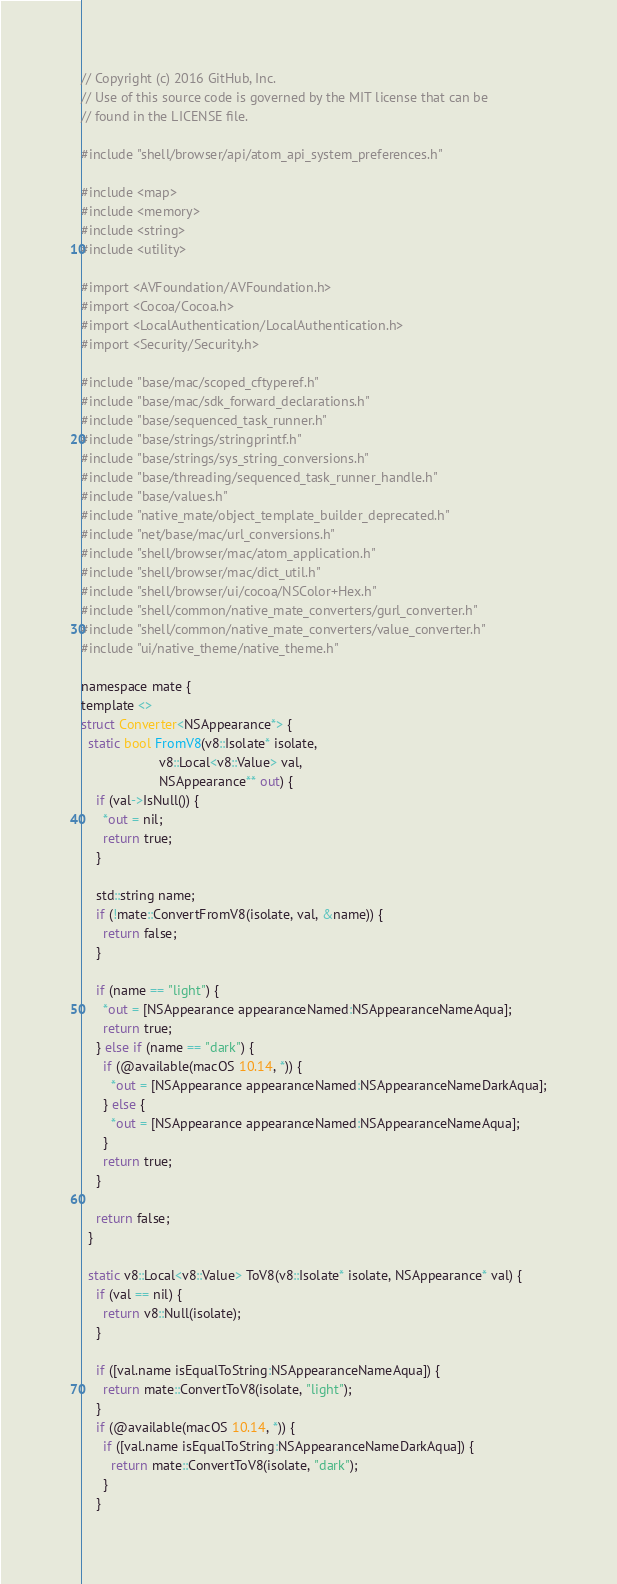Convert code to text. <code><loc_0><loc_0><loc_500><loc_500><_ObjectiveC_>// Copyright (c) 2016 GitHub, Inc.
// Use of this source code is governed by the MIT license that can be
// found in the LICENSE file.

#include "shell/browser/api/atom_api_system_preferences.h"

#include <map>
#include <memory>
#include <string>
#include <utility>

#import <AVFoundation/AVFoundation.h>
#import <Cocoa/Cocoa.h>
#import <LocalAuthentication/LocalAuthentication.h>
#import <Security/Security.h>

#include "base/mac/scoped_cftyperef.h"
#include "base/mac/sdk_forward_declarations.h"
#include "base/sequenced_task_runner.h"
#include "base/strings/stringprintf.h"
#include "base/strings/sys_string_conversions.h"
#include "base/threading/sequenced_task_runner_handle.h"
#include "base/values.h"
#include "native_mate/object_template_builder_deprecated.h"
#include "net/base/mac/url_conversions.h"
#include "shell/browser/mac/atom_application.h"
#include "shell/browser/mac/dict_util.h"
#include "shell/browser/ui/cocoa/NSColor+Hex.h"
#include "shell/common/native_mate_converters/gurl_converter.h"
#include "shell/common/native_mate_converters/value_converter.h"
#include "ui/native_theme/native_theme.h"

namespace mate {
template <>
struct Converter<NSAppearance*> {
  static bool FromV8(v8::Isolate* isolate,
                     v8::Local<v8::Value> val,
                     NSAppearance** out) {
    if (val->IsNull()) {
      *out = nil;
      return true;
    }

    std::string name;
    if (!mate::ConvertFromV8(isolate, val, &name)) {
      return false;
    }

    if (name == "light") {
      *out = [NSAppearance appearanceNamed:NSAppearanceNameAqua];
      return true;
    } else if (name == "dark") {
      if (@available(macOS 10.14, *)) {
        *out = [NSAppearance appearanceNamed:NSAppearanceNameDarkAqua];
      } else {
        *out = [NSAppearance appearanceNamed:NSAppearanceNameAqua];
      }
      return true;
    }

    return false;
  }

  static v8::Local<v8::Value> ToV8(v8::Isolate* isolate, NSAppearance* val) {
    if (val == nil) {
      return v8::Null(isolate);
    }

    if ([val.name isEqualToString:NSAppearanceNameAqua]) {
      return mate::ConvertToV8(isolate, "light");
    }
    if (@available(macOS 10.14, *)) {
      if ([val.name isEqualToString:NSAppearanceNameDarkAqua]) {
        return mate::ConvertToV8(isolate, "dark");
      }
    }
</code> 